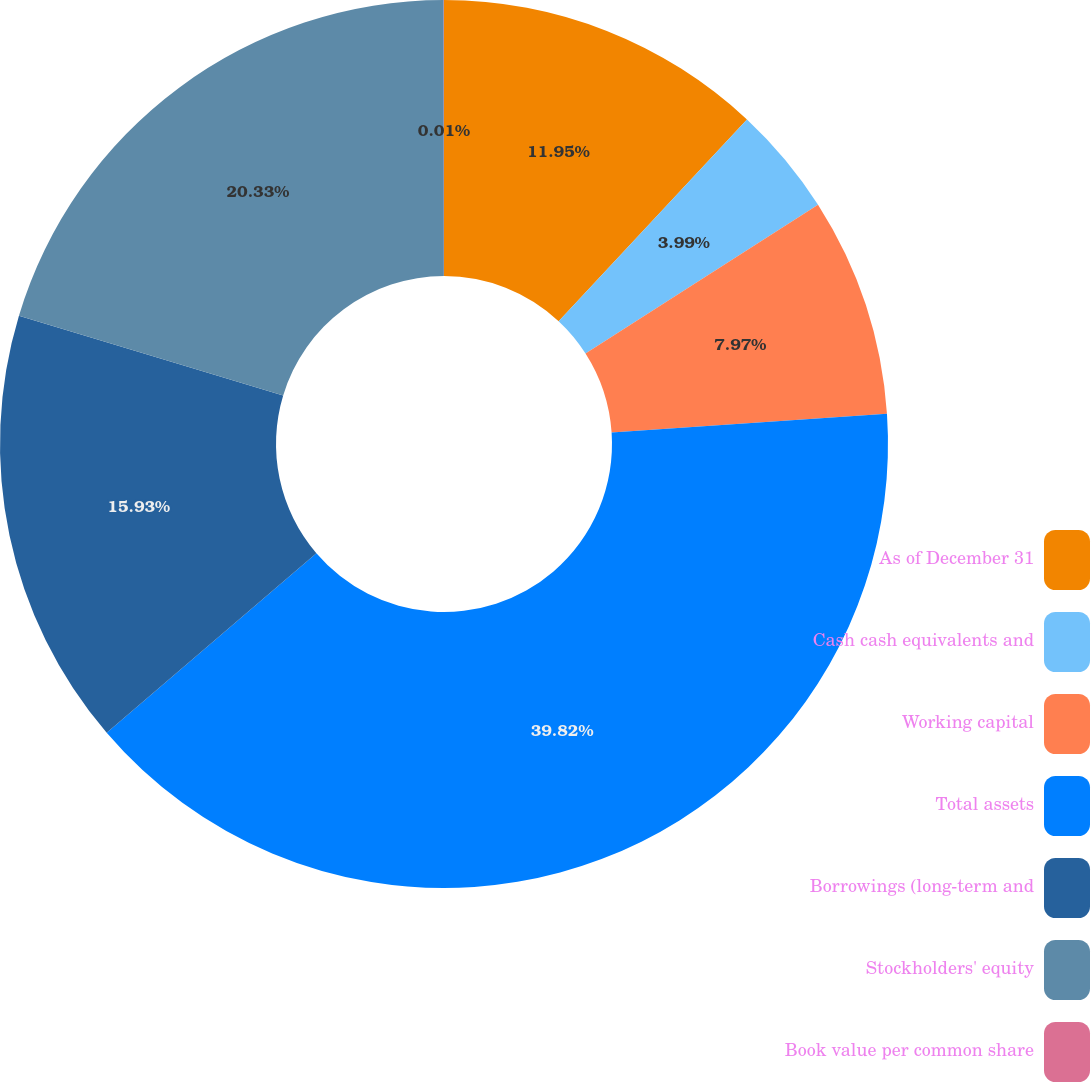Convert chart. <chart><loc_0><loc_0><loc_500><loc_500><pie_chart><fcel>As of December 31<fcel>Cash cash equivalents and<fcel>Working capital<fcel>Total assets<fcel>Borrowings (long-term and<fcel>Stockholders' equity<fcel>Book value per common share<nl><fcel>11.95%<fcel>3.99%<fcel>7.97%<fcel>39.81%<fcel>15.93%<fcel>20.32%<fcel>0.01%<nl></chart> 